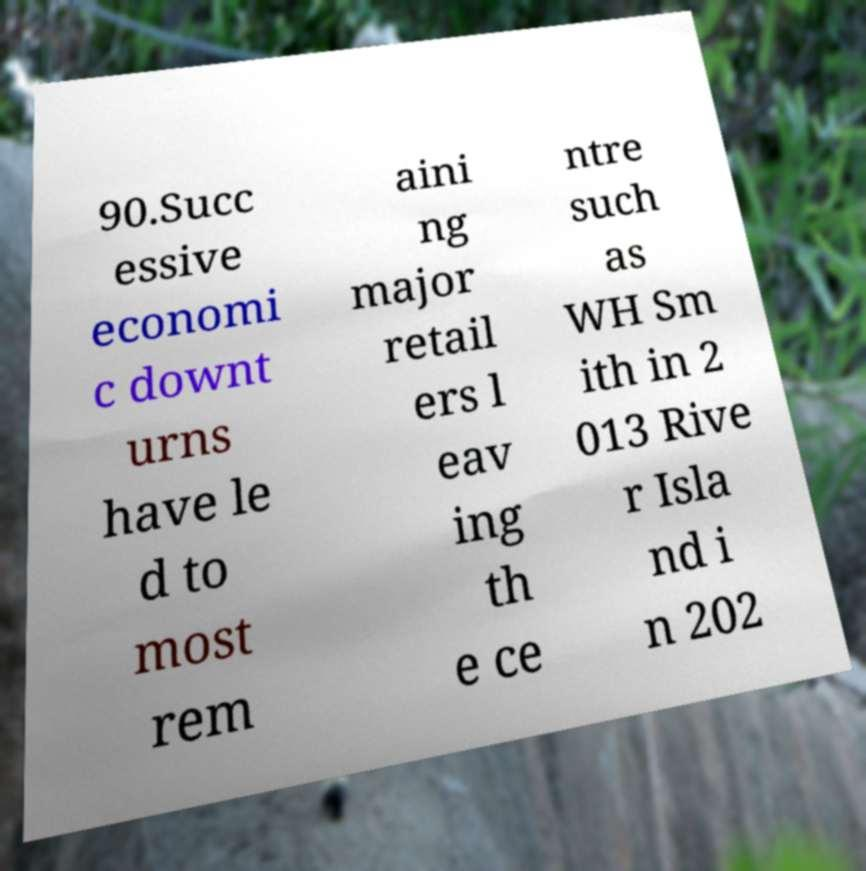Could you assist in decoding the text presented in this image and type it out clearly? 90.Succ essive economi c downt urns have le d to most rem aini ng major retail ers l eav ing th e ce ntre such as WH Sm ith in 2 013 Rive r Isla nd i n 202 